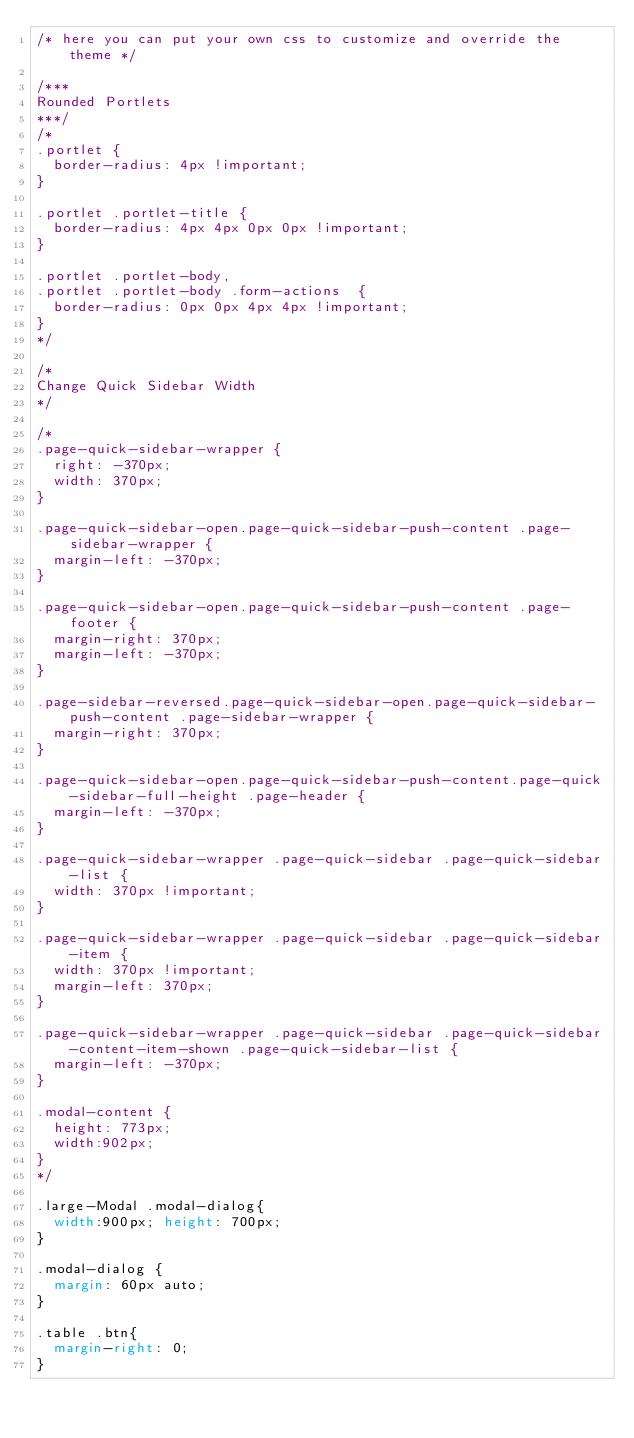<code> <loc_0><loc_0><loc_500><loc_500><_CSS_>/* here you can put your own css to customize and override the theme */

/***
Rounded Portlets
***/
/*
.portlet {
	border-radius: 4px !important;
}

.portlet .portlet-title {
	border-radius: 4px 4px 0px 0px !important;
}

.portlet .portlet-body,
.portlet .portlet-body .form-actions  {
	border-radius: 0px 0px 4px 4px !important;
}
*/

/*
Change Quick Sidebar Width
*/

/*
.page-quick-sidebar-wrapper {
  right: -370px;
  width: 370px;
}

.page-quick-sidebar-open.page-quick-sidebar-push-content .page-sidebar-wrapper {
  margin-left: -370px;
}

.page-quick-sidebar-open.page-quick-sidebar-push-content .page-footer {
  margin-right: 370px;
  margin-left: -370px;
}

.page-sidebar-reversed.page-quick-sidebar-open.page-quick-sidebar-push-content .page-sidebar-wrapper {
  margin-right: 370px;
}

.page-quick-sidebar-open.page-quick-sidebar-push-content.page-quick-sidebar-full-height .page-header {
  margin-left: -370px;
}

.page-quick-sidebar-wrapper .page-quick-sidebar .page-quick-sidebar-list {
  width: 370px !important;
}

.page-quick-sidebar-wrapper .page-quick-sidebar .page-quick-sidebar-item {
  width: 370px !important;
  margin-left: 370px;
}

.page-quick-sidebar-wrapper .page-quick-sidebar .page-quick-sidebar-content-item-shown .page-quick-sidebar-list {
  margin-left: -370px;
}

.modal-content {
  height: 773px;
  width:902px;
}
*/

.large-Modal .modal-dialog{
  width:900px; height: 700px;
}

.modal-dialog {
  margin: 60px auto;
}

.table .btn{
  margin-right: 0;
}


</code> 